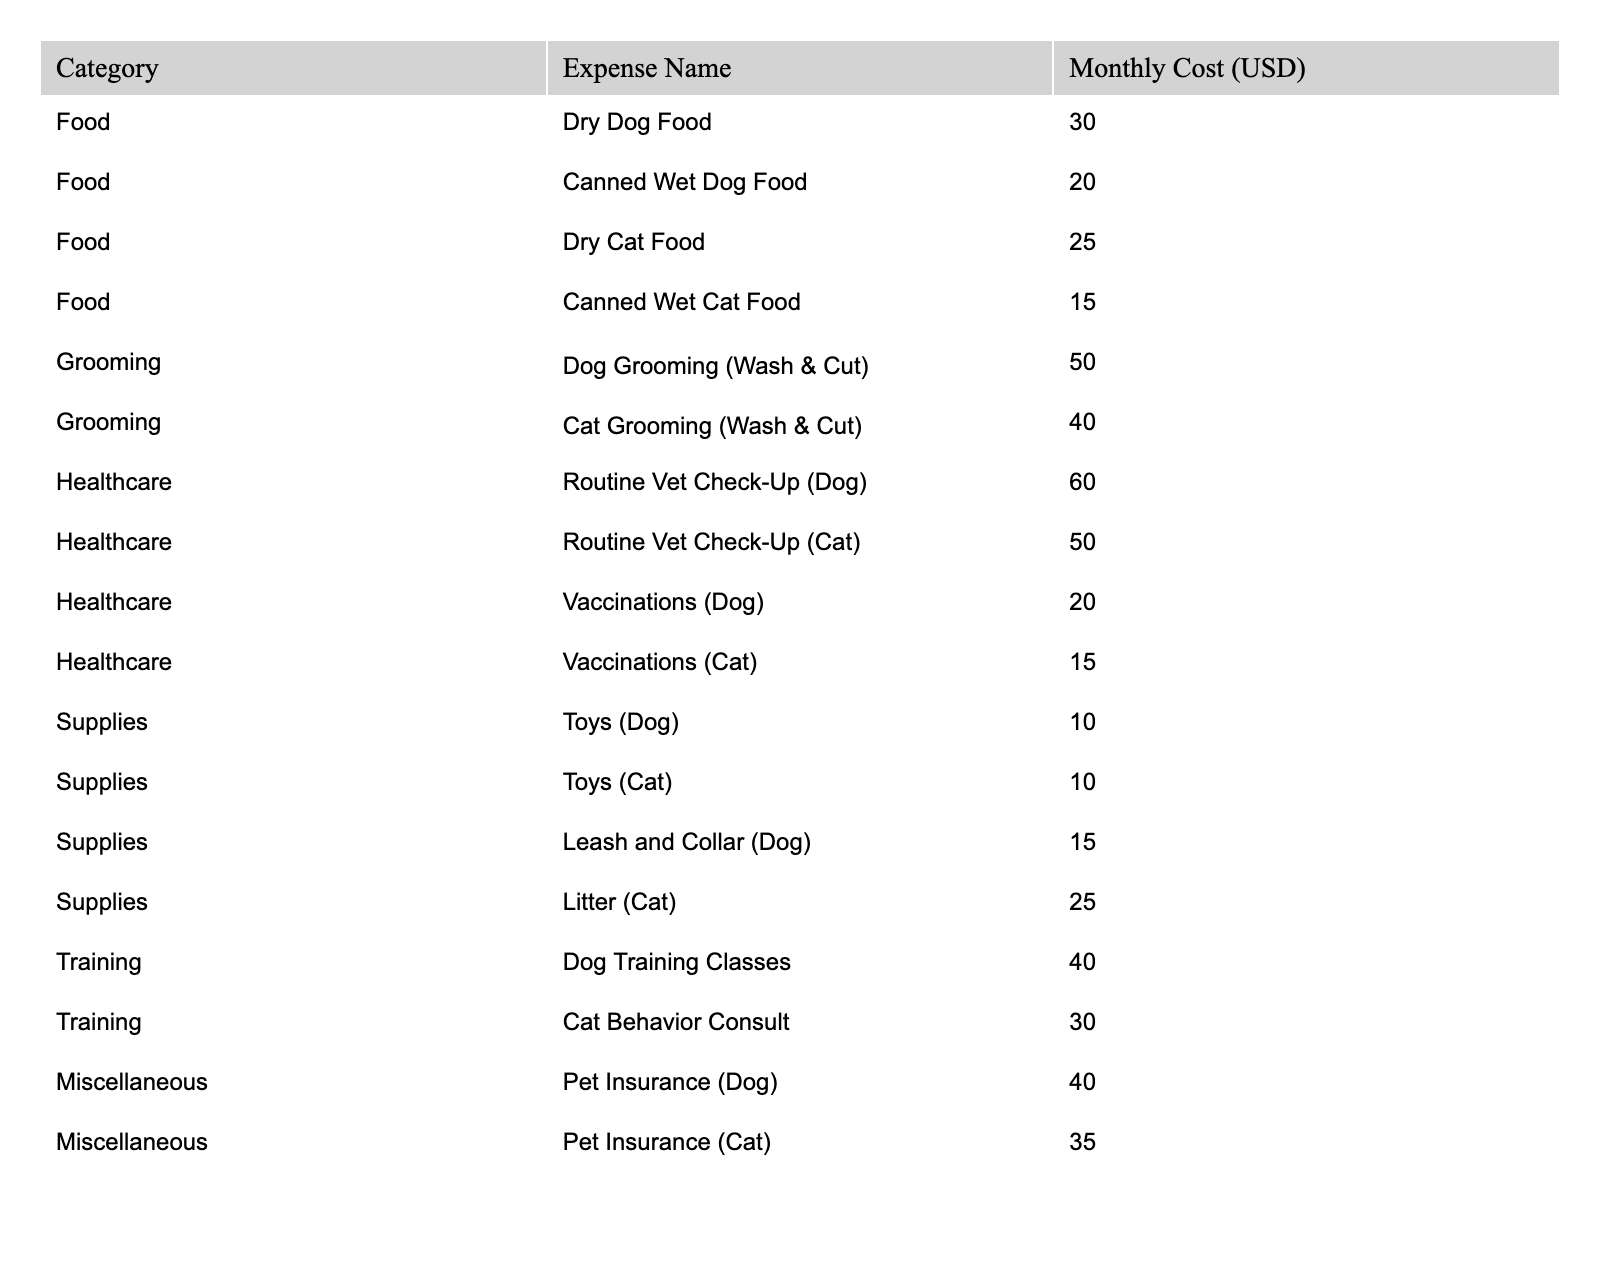What's the total monthly expense for dog grooming? The table shows that dog grooming costs $50. There are no other dog grooming expenses listed under different categories, so the total expense is simply $50.
Answer: 50 What is the cost of canned wet cat food? According to the table, the expense for canned wet cat food is listed as $15. This is a straightforward retrieval from the table.
Answer: 15 How much do vaccinations for both dogs and cats cost combined? The cost for dog vaccinations is $20, and for cat vaccinations, it is $15. To find the combined cost, you sum these two amounts: $20 + $15 = $35.
Answer: 35 Which is more expensive, routine vet check-ups for dogs or cats? The routine vet check-up for dogs costs $60, while for cats, it costs $50. Since $60 > $50, the dog vet check-up is more expensive.
Answer: Dog vet check-up What is the total monthly expense for food for both dogs and cats? The monthly expenses for dog food (dry and canned) are $30 + $20 = $50, and for cat food (dry and canned) they are $25 + $15 = $40. Adding both totals gives $50 + $40 = $90.
Answer: 90 Are dog behavior training classes more expensive than cat behavior consultations? Dog training classes cost $40, while cat behavior consultations cost $30. Since $40 > $30, dog classes are more expensive.
Answer: Yes What is the average monthly expense for healthcare between dogs and cats? For dogs, the total healthcare costs are $60 (check-up) + $20 (vaccinations) = $80. For cats, it is $50 (check-up) + $15 (vaccinations) = $65. The total for both is $80 + $65 = $145. There are 4 data points (two for dogs and two for cats), so the average is $145 / 4 = $36.25.
Answer: 36.25 What is the total cost of supplies for pets? The total supply costs from the table are: Dog toys $10 + Cat toys $10 + Dog leash and collar $15 + Cat litter $25. Adding these gives $10 + $10 + $15 + $25 = $60.
Answer: 60 Is the total monthly expense for pet insurance greater for dogs or cats? The pet insurance for dogs costs $40, while for cats, it costs $35. Therefore, $40 > $35, showing that dog insurance is more expensive.
Answer: Dog insurance What is the total monthly expense for all pet categories combined? To calculate this, sum all expenses: 30 + 20 + 25 + 15 + 50 + 40 + 60 + 50 + 20 + 15 + 10 + 10 + 15 + 25 + 40 + 30 + 40 + 35. The total is $445.
Answer: 445 